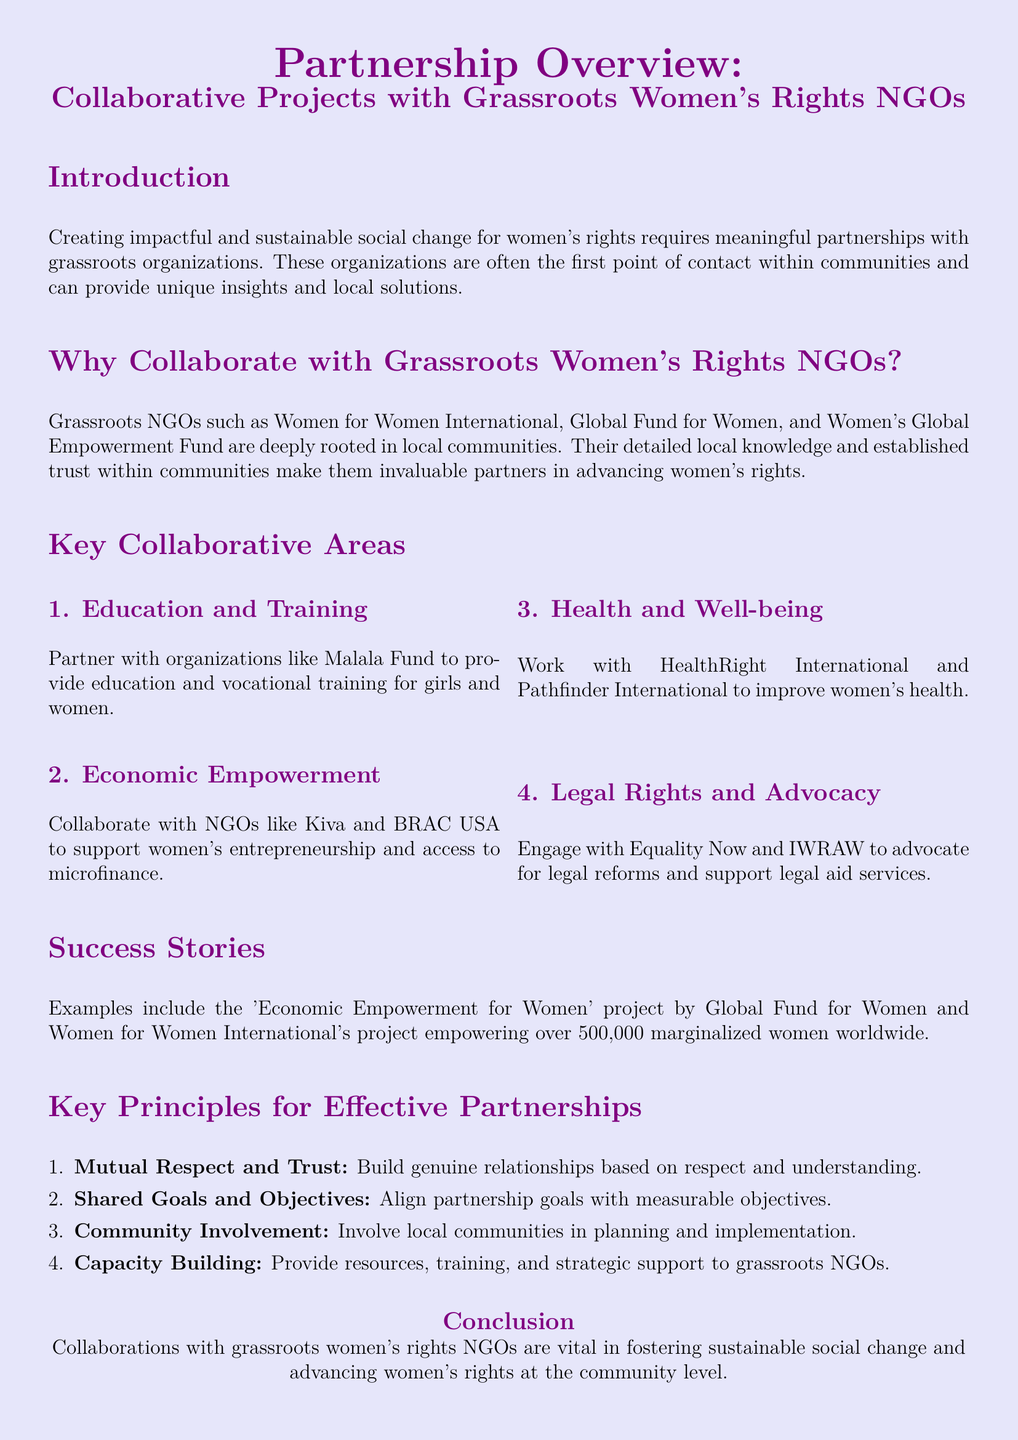What are some organizations mentioned for education and training? The document lists Malala Fund as a key partner for education and training initiatives for girls and women.
Answer: Malala Fund Which grassroots organization focuses on women's economic empowerment? Kiva and BRAC USA are mentioned as organizations that support women's entrepreneurship and access to microfinance.
Answer: Kiva and BRAC USA What is one of the key principles for effective partnerships? The document mentions "Mutual Respect and Trust" as a key principle for effective partnerships with grassroots NGOs.
Answer: Mutual Respect and Trust How many marginalized women have been empowered by Women for Women International's project? The success story highlights that the project has empowered over 500,000 marginalized women.
Answer: 500,000 What is the primary purpose of collaborating with grassroots women's rights NGOs? The introduction states that creating impactful and sustainable social change for women's rights requires meaningful partnerships with these NGOs.
Answer: Social change for women's rights 